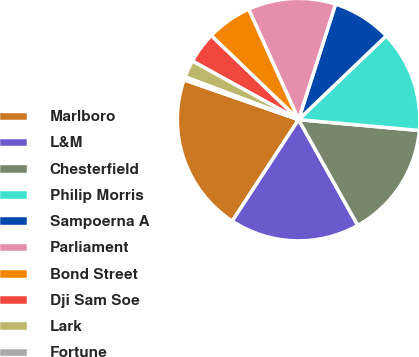<chart> <loc_0><loc_0><loc_500><loc_500><pie_chart><fcel>Marlboro<fcel>L&M<fcel>Chesterfield<fcel>Philip Morris<fcel>Sampoerna A<fcel>Parliament<fcel>Bond Street<fcel>Dji Sam Soe<fcel>Lark<fcel>Fortune<nl><fcel>21.1%<fcel>17.34%<fcel>15.45%<fcel>13.57%<fcel>7.93%<fcel>11.69%<fcel>6.05%<fcel>4.17%<fcel>2.29%<fcel>0.41%<nl></chart> 